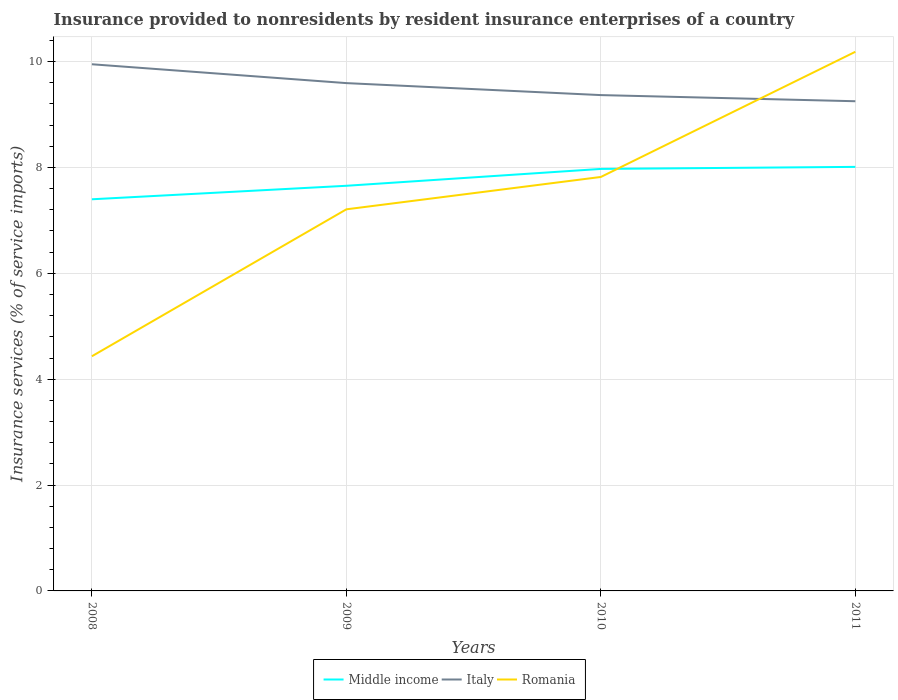Across all years, what is the maximum insurance provided to nonresidents in Middle income?
Provide a short and direct response. 7.4. What is the total insurance provided to nonresidents in Middle income in the graph?
Keep it short and to the point. -0.36. What is the difference between the highest and the second highest insurance provided to nonresidents in Middle income?
Ensure brevity in your answer.  0.61. How many lines are there?
Give a very brief answer. 3. Does the graph contain any zero values?
Your response must be concise. No. Does the graph contain grids?
Keep it short and to the point. Yes. How many legend labels are there?
Ensure brevity in your answer.  3. What is the title of the graph?
Offer a terse response. Insurance provided to nonresidents by resident insurance enterprises of a country. Does "Least developed countries" appear as one of the legend labels in the graph?
Provide a short and direct response. No. What is the label or title of the X-axis?
Your response must be concise. Years. What is the label or title of the Y-axis?
Keep it short and to the point. Insurance services (% of service imports). What is the Insurance services (% of service imports) in Middle income in 2008?
Your response must be concise. 7.4. What is the Insurance services (% of service imports) in Italy in 2008?
Give a very brief answer. 9.95. What is the Insurance services (% of service imports) in Romania in 2008?
Ensure brevity in your answer.  4.43. What is the Insurance services (% of service imports) in Middle income in 2009?
Provide a succinct answer. 7.65. What is the Insurance services (% of service imports) in Italy in 2009?
Give a very brief answer. 9.59. What is the Insurance services (% of service imports) in Romania in 2009?
Keep it short and to the point. 7.21. What is the Insurance services (% of service imports) of Middle income in 2010?
Offer a very short reply. 7.97. What is the Insurance services (% of service imports) in Italy in 2010?
Keep it short and to the point. 9.37. What is the Insurance services (% of service imports) in Romania in 2010?
Give a very brief answer. 7.82. What is the Insurance services (% of service imports) of Middle income in 2011?
Make the answer very short. 8.01. What is the Insurance services (% of service imports) in Italy in 2011?
Provide a short and direct response. 9.25. What is the Insurance services (% of service imports) in Romania in 2011?
Your answer should be compact. 10.19. Across all years, what is the maximum Insurance services (% of service imports) in Middle income?
Make the answer very short. 8.01. Across all years, what is the maximum Insurance services (% of service imports) of Italy?
Provide a succinct answer. 9.95. Across all years, what is the maximum Insurance services (% of service imports) in Romania?
Give a very brief answer. 10.19. Across all years, what is the minimum Insurance services (% of service imports) of Middle income?
Make the answer very short. 7.4. Across all years, what is the minimum Insurance services (% of service imports) in Italy?
Provide a succinct answer. 9.25. Across all years, what is the minimum Insurance services (% of service imports) in Romania?
Your response must be concise. 4.43. What is the total Insurance services (% of service imports) in Middle income in the graph?
Provide a short and direct response. 31.04. What is the total Insurance services (% of service imports) of Italy in the graph?
Your answer should be compact. 38.16. What is the total Insurance services (% of service imports) of Romania in the graph?
Provide a succinct answer. 29.65. What is the difference between the Insurance services (% of service imports) in Middle income in 2008 and that in 2009?
Ensure brevity in your answer.  -0.26. What is the difference between the Insurance services (% of service imports) in Italy in 2008 and that in 2009?
Keep it short and to the point. 0.36. What is the difference between the Insurance services (% of service imports) in Romania in 2008 and that in 2009?
Your response must be concise. -2.78. What is the difference between the Insurance services (% of service imports) in Middle income in 2008 and that in 2010?
Provide a succinct answer. -0.57. What is the difference between the Insurance services (% of service imports) in Italy in 2008 and that in 2010?
Provide a short and direct response. 0.58. What is the difference between the Insurance services (% of service imports) in Romania in 2008 and that in 2010?
Give a very brief answer. -3.39. What is the difference between the Insurance services (% of service imports) of Middle income in 2008 and that in 2011?
Provide a short and direct response. -0.61. What is the difference between the Insurance services (% of service imports) of Italy in 2008 and that in 2011?
Offer a very short reply. 0.7. What is the difference between the Insurance services (% of service imports) in Romania in 2008 and that in 2011?
Ensure brevity in your answer.  -5.75. What is the difference between the Insurance services (% of service imports) of Middle income in 2009 and that in 2010?
Your answer should be compact. -0.32. What is the difference between the Insurance services (% of service imports) of Italy in 2009 and that in 2010?
Your answer should be compact. 0.23. What is the difference between the Insurance services (% of service imports) in Romania in 2009 and that in 2010?
Your response must be concise. -0.61. What is the difference between the Insurance services (% of service imports) in Middle income in 2009 and that in 2011?
Offer a terse response. -0.36. What is the difference between the Insurance services (% of service imports) of Italy in 2009 and that in 2011?
Your answer should be very brief. 0.34. What is the difference between the Insurance services (% of service imports) of Romania in 2009 and that in 2011?
Provide a succinct answer. -2.98. What is the difference between the Insurance services (% of service imports) in Middle income in 2010 and that in 2011?
Keep it short and to the point. -0.04. What is the difference between the Insurance services (% of service imports) in Italy in 2010 and that in 2011?
Offer a terse response. 0.12. What is the difference between the Insurance services (% of service imports) in Romania in 2010 and that in 2011?
Make the answer very short. -2.36. What is the difference between the Insurance services (% of service imports) in Middle income in 2008 and the Insurance services (% of service imports) in Italy in 2009?
Provide a short and direct response. -2.19. What is the difference between the Insurance services (% of service imports) of Middle income in 2008 and the Insurance services (% of service imports) of Romania in 2009?
Your response must be concise. 0.19. What is the difference between the Insurance services (% of service imports) of Italy in 2008 and the Insurance services (% of service imports) of Romania in 2009?
Offer a very short reply. 2.74. What is the difference between the Insurance services (% of service imports) in Middle income in 2008 and the Insurance services (% of service imports) in Italy in 2010?
Offer a very short reply. -1.97. What is the difference between the Insurance services (% of service imports) of Middle income in 2008 and the Insurance services (% of service imports) of Romania in 2010?
Provide a short and direct response. -0.42. What is the difference between the Insurance services (% of service imports) of Italy in 2008 and the Insurance services (% of service imports) of Romania in 2010?
Your answer should be very brief. 2.13. What is the difference between the Insurance services (% of service imports) in Middle income in 2008 and the Insurance services (% of service imports) in Italy in 2011?
Keep it short and to the point. -1.85. What is the difference between the Insurance services (% of service imports) in Middle income in 2008 and the Insurance services (% of service imports) in Romania in 2011?
Make the answer very short. -2.79. What is the difference between the Insurance services (% of service imports) in Italy in 2008 and the Insurance services (% of service imports) in Romania in 2011?
Keep it short and to the point. -0.24. What is the difference between the Insurance services (% of service imports) in Middle income in 2009 and the Insurance services (% of service imports) in Italy in 2010?
Offer a very short reply. -1.71. What is the difference between the Insurance services (% of service imports) in Middle income in 2009 and the Insurance services (% of service imports) in Romania in 2010?
Provide a succinct answer. -0.17. What is the difference between the Insurance services (% of service imports) in Italy in 2009 and the Insurance services (% of service imports) in Romania in 2010?
Keep it short and to the point. 1.77. What is the difference between the Insurance services (% of service imports) of Middle income in 2009 and the Insurance services (% of service imports) of Italy in 2011?
Your answer should be compact. -1.6. What is the difference between the Insurance services (% of service imports) of Middle income in 2009 and the Insurance services (% of service imports) of Romania in 2011?
Ensure brevity in your answer.  -2.53. What is the difference between the Insurance services (% of service imports) of Italy in 2009 and the Insurance services (% of service imports) of Romania in 2011?
Offer a terse response. -0.59. What is the difference between the Insurance services (% of service imports) in Middle income in 2010 and the Insurance services (% of service imports) in Italy in 2011?
Provide a succinct answer. -1.28. What is the difference between the Insurance services (% of service imports) in Middle income in 2010 and the Insurance services (% of service imports) in Romania in 2011?
Offer a very short reply. -2.21. What is the difference between the Insurance services (% of service imports) in Italy in 2010 and the Insurance services (% of service imports) in Romania in 2011?
Provide a succinct answer. -0.82. What is the average Insurance services (% of service imports) of Middle income per year?
Ensure brevity in your answer.  7.76. What is the average Insurance services (% of service imports) in Italy per year?
Make the answer very short. 9.54. What is the average Insurance services (% of service imports) in Romania per year?
Make the answer very short. 7.41. In the year 2008, what is the difference between the Insurance services (% of service imports) in Middle income and Insurance services (% of service imports) in Italy?
Your response must be concise. -2.55. In the year 2008, what is the difference between the Insurance services (% of service imports) in Middle income and Insurance services (% of service imports) in Romania?
Make the answer very short. 2.97. In the year 2008, what is the difference between the Insurance services (% of service imports) in Italy and Insurance services (% of service imports) in Romania?
Make the answer very short. 5.52. In the year 2009, what is the difference between the Insurance services (% of service imports) in Middle income and Insurance services (% of service imports) in Italy?
Provide a short and direct response. -1.94. In the year 2009, what is the difference between the Insurance services (% of service imports) in Middle income and Insurance services (% of service imports) in Romania?
Provide a succinct answer. 0.44. In the year 2009, what is the difference between the Insurance services (% of service imports) of Italy and Insurance services (% of service imports) of Romania?
Your answer should be compact. 2.38. In the year 2010, what is the difference between the Insurance services (% of service imports) in Middle income and Insurance services (% of service imports) in Italy?
Provide a short and direct response. -1.39. In the year 2010, what is the difference between the Insurance services (% of service imports) in Middle income and Insurance services (% of service imports) in Romania?
Provide a short and direct response. 0.15. In the year 2010, what is the difference between the Insurance services (% of service imports) in Italy and Insurance services (% of service imports) in Romania?
Make the answer very short. 1.55. In the year 2011, what is the difference between the Insurance services (% of service imports) in Middle income and Insurance services (% of service imports) in Italy?
Give a very brief answer. -1.24. In the year 2011, what is the difference between the Insurance services (% of service imports) of Middle income and Insurance services (% of service imports) of Romania?
Provide a succinct answer. -2.17. In the year 2011, what is the difference between the Insurance services (% of service imports) in Italy and Insurance services (% of service imports) in Romania?
Provide a succinct answer. -0.93. What is the ratio of the Insurance services (% of service imports) of Middle income in 2008 to that in 2009?
Provide a succinct answer. 0.97. What is the ratio of the Insurance services (% of service imports) in Italy in 2008 to that in 2009?
Your answer should be compact. 1.04. What is the ratio of the Insurance services (% of service imports) of Romania in 2008 to that in 2009?
Give a very brief answer. 0.61. What is the ratio of the Insurance services (% of service imports) in Middle income in 2008 to that in 2010?
Your answer should be very brief. 0.93. What is the ratio of the Insurance services (% of service imports) of Italy in 2008 to that in 2010?
Keep it short and to the point. 1.06. What is the ratio of the Insurance services (% of service imports) of Romania in 2008 to that in 2010?
Your answer should be compact. 0.57. What is the ratio of the Insurance services (% of service imports) in Middle income in 2008 to that in 2011?
Ensure brevity in your answer.  0.92. What is the ratio of the Insurance services (% of service imports) in Italy in 2008 to that in 2011?
Make the answer very short. 1.08. What is the ratio of the Insurance services (% of service imports) in Romania in 2008 to that in 2011?
Offer a terse response. 0.44. What is the ratio of the Insurance services (% of service imports) of Middle income in 2009 to that in 2010?
Your answer should be compact. 0.96. What is the ratio of the Insurance services (% of service imports) in Italy in 2009 to that in 2010?
Your answer should be compact. 1.02. What is the ratio of the Insurance services (% of service imports) of Romania in 2009 to that in 2010?
Provide a succinct answer. 0.92. What is the ratio of the Insurance services (% of service imports) of Middle income in 2009 to that in 2011?
Keep it short and to the point. 0.96. What is the ratio of the Insurance services (% of service imports) of Romania in 2009 to that in 2011?
Your answer should be compact. 0.71. What is the ratio of the Insurance services (% of service imports) in Middle income in 2010 to that in 2011?
Your answer should be compact. 1. What is the ratio of the Insurance services (% of service imports) of Italy in 2010 to that in 2011?
Offer a terse response. 1.01. What is the ratio of the Insurance services (% of service imports) in Romania in 2010 to that in 2011?
Ensure brevity in your answer.  0.77. What is the difference between the highest and the second highest Insurance services (% of service imports) in Middle income?
Provide a succinct answer. 0.04. What is the difference between the highest and the second highest Insurance services (% of service imports) of Italy?
Your answer should be very brief. 0.36. What is the difference between the highest and the second highest Insurance services (% of service imports) of Romania?
Your answer should be compact. 2.36. What is the difference between the highest and the lowest Insurance services (% of service imports) of Middle income?
Your answer should be very brief. 0.61. What is the difference between the highest and the lowest Insurance services (% of service imports) of Italy?
Your response must be concise. 0.7. What is the difference between the highest and the lowest Insurance services (% of service imports) in Romania?
Keep it short and to the point. 5.75. 